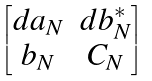Convert formula to latex. <formula><loc_0><loc_0><loc_500><loc_500>\begin{bmatrix} d a _ { N } & d b _ { N } ^ { * } \\ b _ { N } & C _ { N } \\ \end{bmatrix}</formula> 